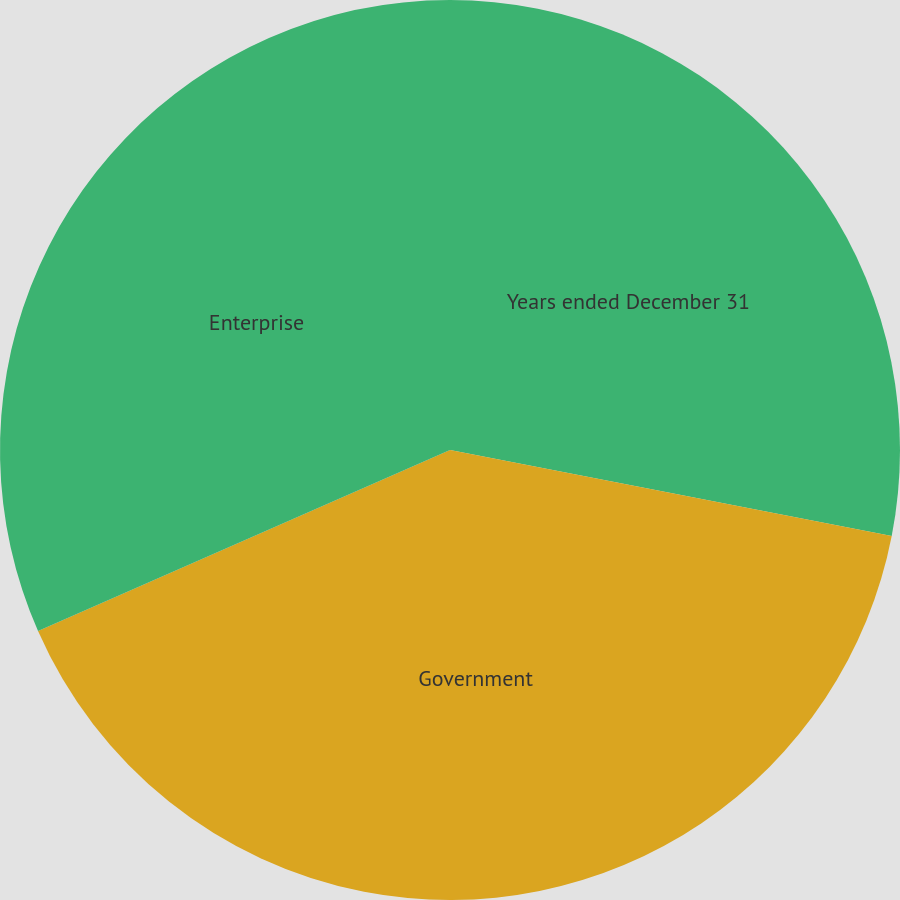Convert chart to OTSL. <chart><loc_0><loc_0><loc_500><loc_500><pie_chart><fcel>Years ended December 31<fcel>Government<fcel>Enterprise<nl><fcel>28.06%<fcel>40.35%<fcel>31.59%<nl></chart> 